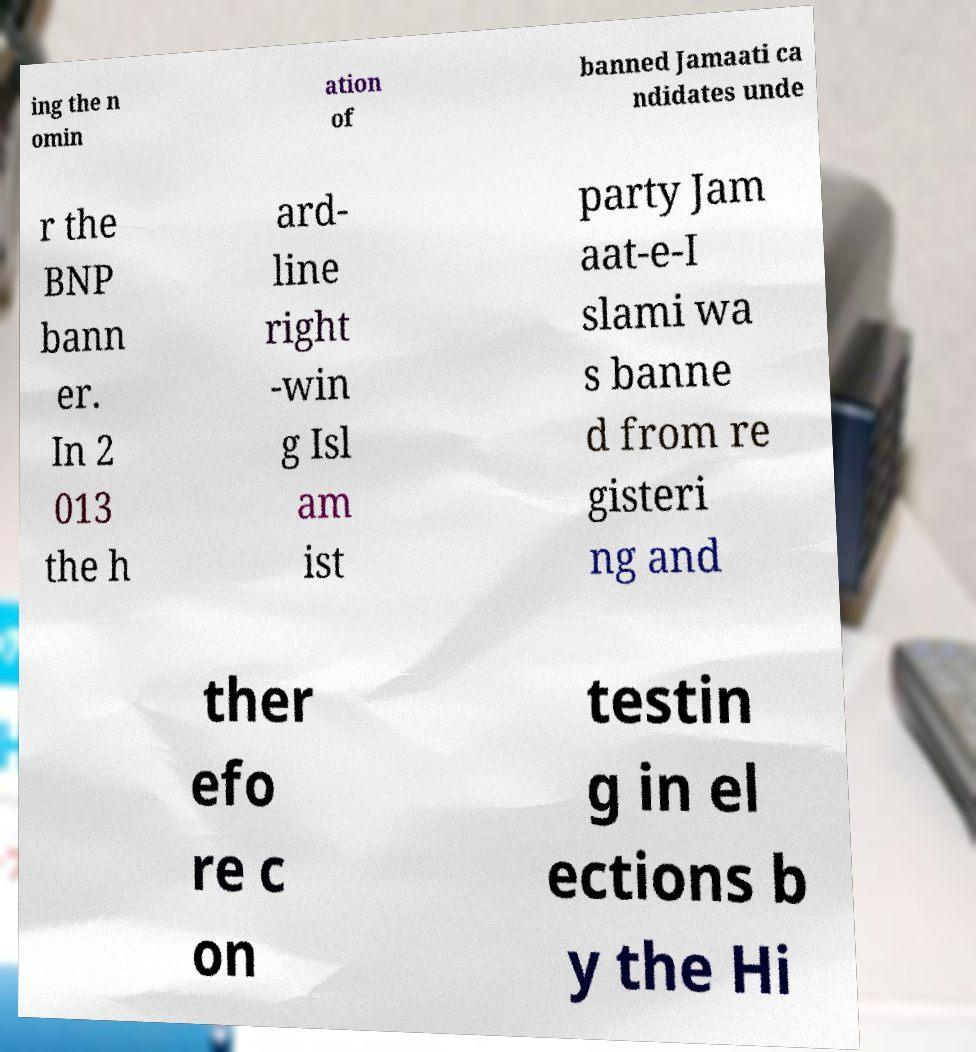Can you read and provide the text displayed in the image?This photo seems to have some interesting text. Can you extract and type it out for me? ing the n omin ation of banned Jamaati ca ndidates unde r the BNP bann er. In 2 013 the h ard- line right -win g Isl am ist party Jam aat-e-I slami wa s banne d from re gisteri ng and ther efo re c on testin g in el ections b y the Hi 